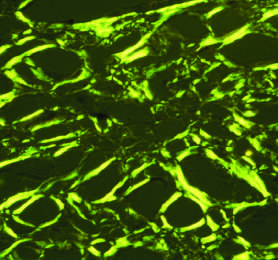what shows apple-green birefringence under polarized light, a diagnostic feature of amyloid?
Answer the question using a single word or phrase. Congo red staining 